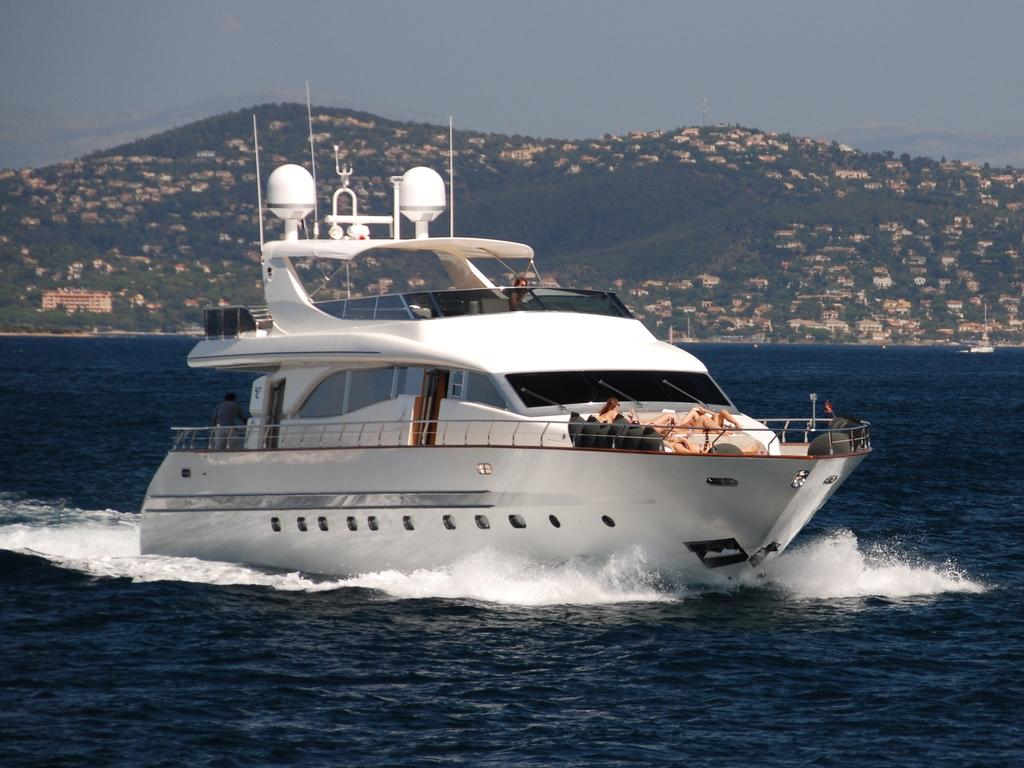What is the main subject of the image? There is a ship in the water. Are there any people on the ship? Yes, there are people on the ship. What else can be seen in the image besides the ship and people? Buildings, trees, mountains, and the sky are visible in the image. Where is the faucet located in the image? There is no faucet present in the image. What type of sponge is being used by the people on the ship? There is no sponge visible in the image, and it is not clear what the people on the ship might be using. 